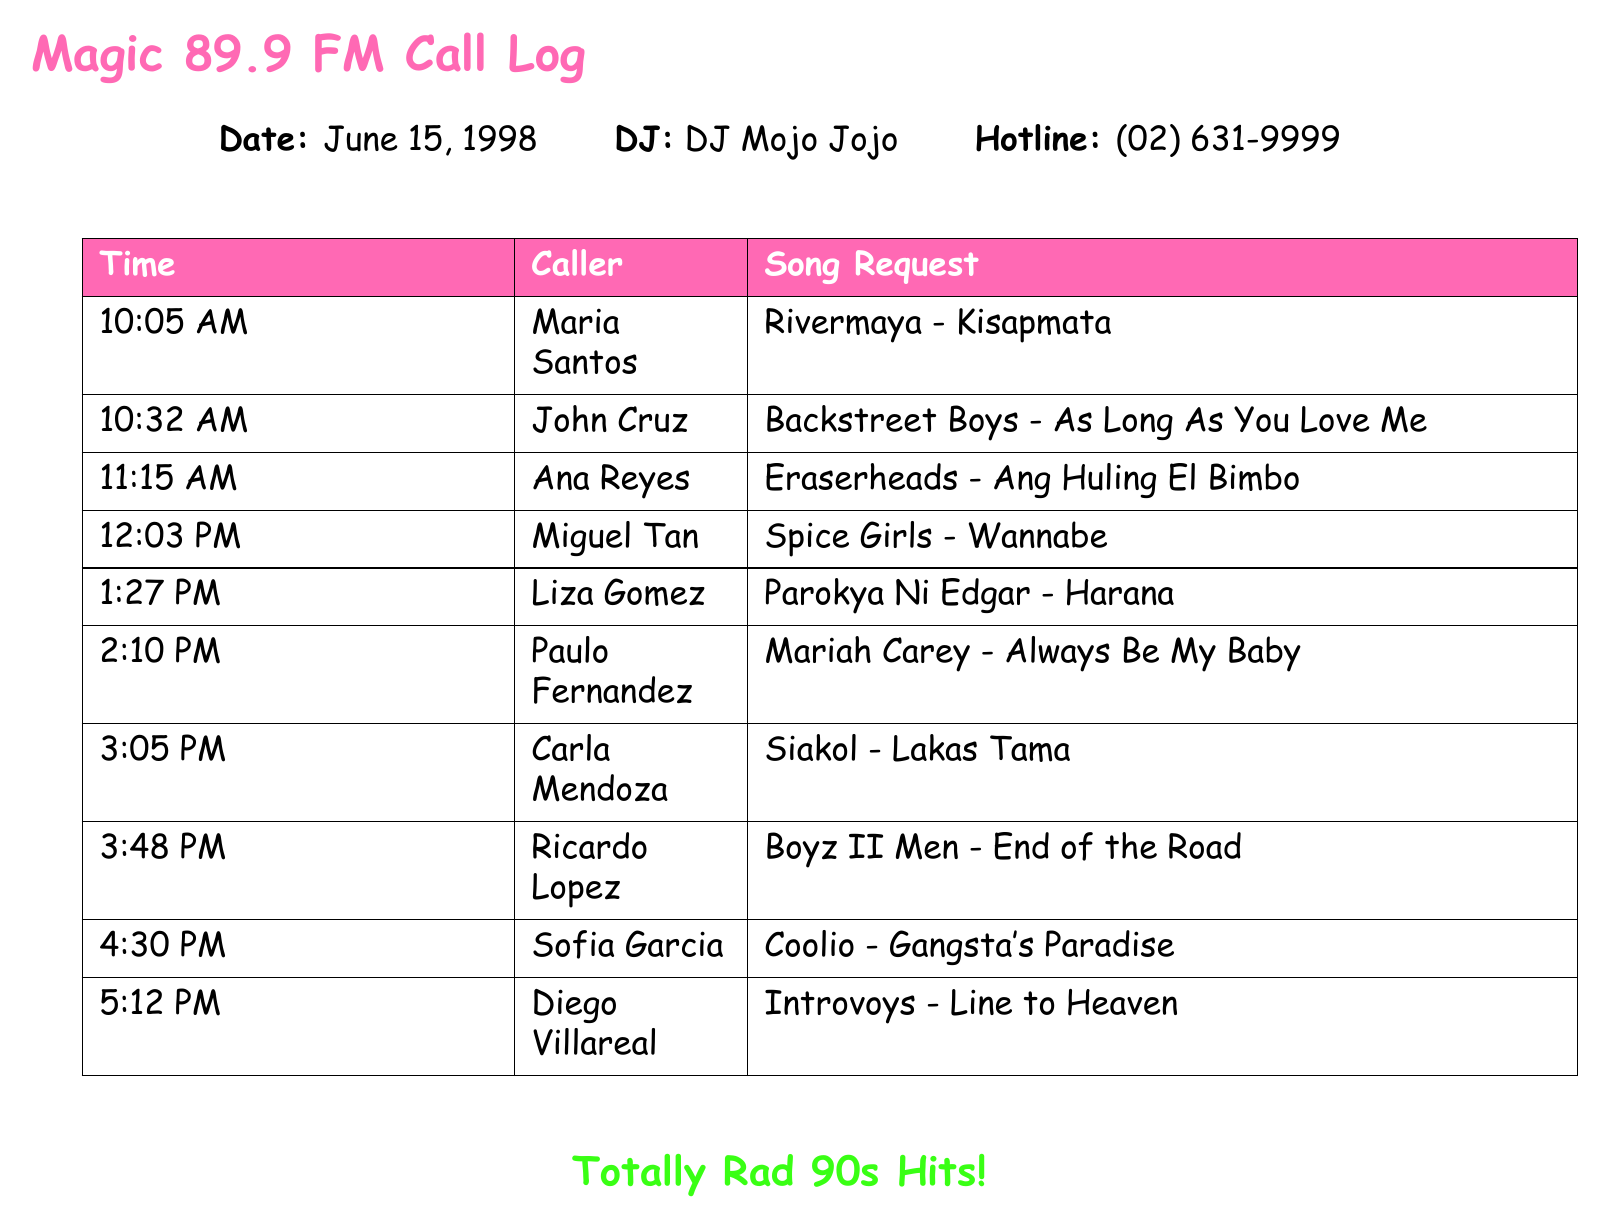What is the date of the call log? The date is stated at the beginning of the document under "Date".
Answer: June 15, 1998 Who was the DJ for the call log? The DJ's name is provided next to "DJ" at the start of the document.
Answer: DJ Mojo Jojo What song did Maria Santos request? The song requested by Maria Santos is listed under her name in the call log.
Answer: Rivermaya - Kisapmata Which caller requested "Gangsta's Paradise"? The caller's name requesting this song can be found in the table next to the song title.
Answer: Sofia Garcia What was the time of the first call? The time of the first call is the earliest timestamp listed in the call log table.
Answer: 10:05 AM How many total calls are logged? The total number of calls can be counted from the entries in the call log.
Answer: 10 Which boy band has a song request in the log? A specific entry can be found in the table that mentions a boy band.
Answer: Backstreet Boys Was there a request for a song by Eraserheads? The document contains a request for a song by this Filipino band, which can be identified in the log.
Answer: Yes What was the last song requested? The last song in the time order listed in the table indicates this.
Answer: Introvoys - Line to Heaven 